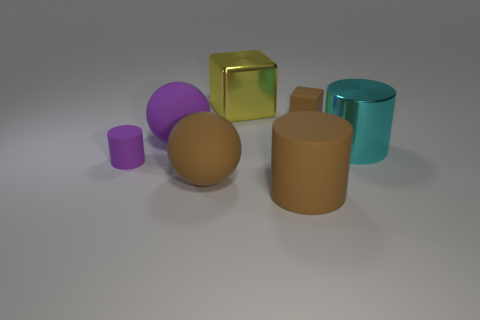There is a large cylinder on the left side of the matte block; is it the same color as the rubber cube?
Provide a short and direct response. Yes. Are there the same number of large purple spheres that are on the right side of the big brown ball and big brown matte balls in front of the small purple matte thing?
Ensure brevity in your answer.  No. What color is the shiny thing that is behind the matte cube?
Give a very brief answer. Yellow. Are there the same number of big blocks to the right of the brown rubber cylinder and small gray metal blocks?
Provide a short and direct response. Yes. What number of other objects are there of the same shape as the cyan thing?
Provide a short and direct response. 2. There is a brown sphere; how many cylinders are in front of it?
Ensure brevity in your answer.  1. There is a cylinder that is left of the tiny brown thing and to the right of the small purple matte thing; how big is it?
Ensure brevity in your answer.  Large. Is there a green ball?
Your answer should be compact. No. What number of other objects are there of the same size as the cyan metal object?
Give a very brief answer. 4. Is the color of the matte cylinder that is on the right side of the tiny purple cylinder the same as the tiny rubber thing that is behind the small cylinder?
Provide a succinct answer. Yes. 